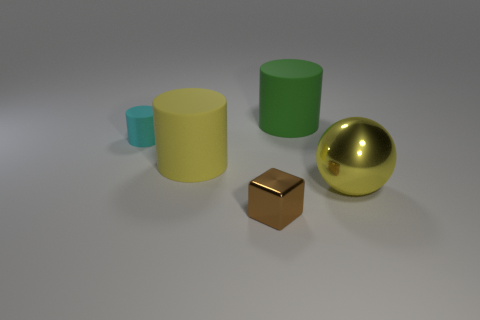Add 2 metal spheres. How many objects exist? 7 Subtract all large cylinders. How many cylinders are left? 1 Subtract all cylinders. How many objects are left? 2 Subtract all big cyan rubber objects. Subtract all tiny cylinders. How many objects are left? 4 Add 2 large yellow shiny things. How many large yellow shiny things are left? 3 Add 4 red objects. How many red objects exist? 4 Subtract 0 cyan balls. How many objects are left? 5 